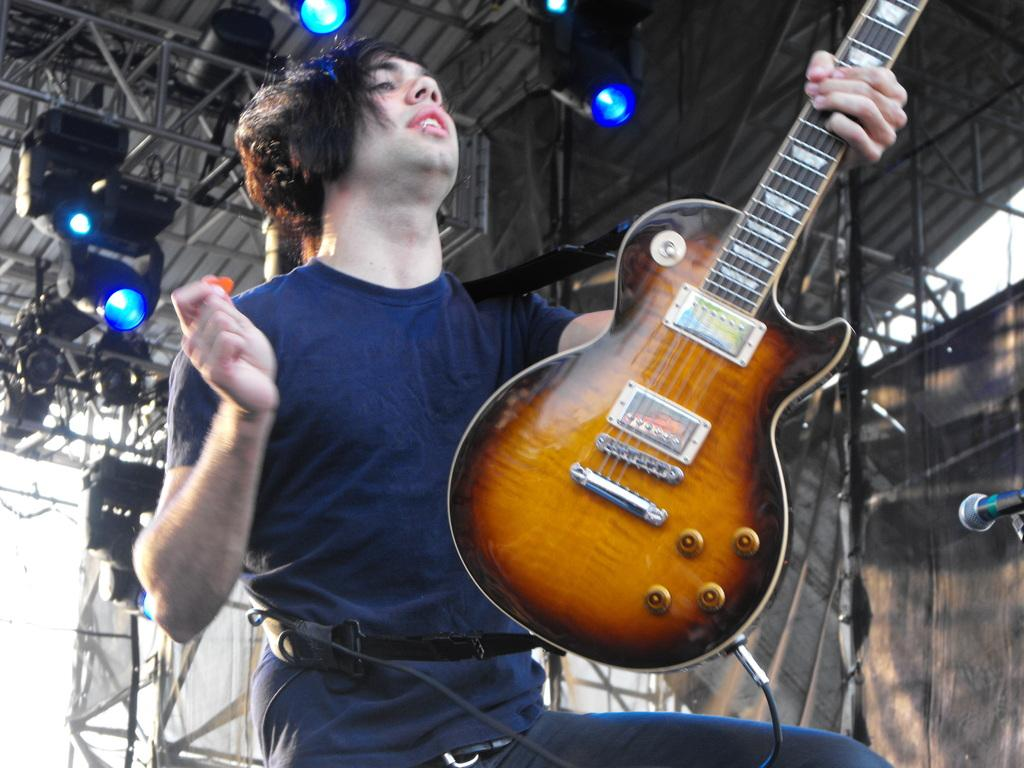What is the man in the image holding? The man is holding a guitar. What object is present for amplifying sound in the image? There is a microphone in the image. What can be seen in the background of the image? Equipment and lights are visible in the background. What month is it in the image? The month cannot be determined from the image, as there is no information about the date or time of year. How many apples are on the guitar in the image? There are no apples present in the image; the man is holding a guitar. 